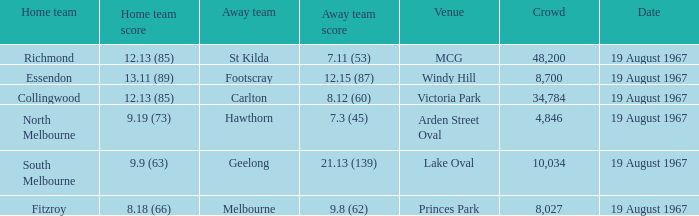If the away team scored 7.3 (45), what was the home team score? 9.19 (73). 